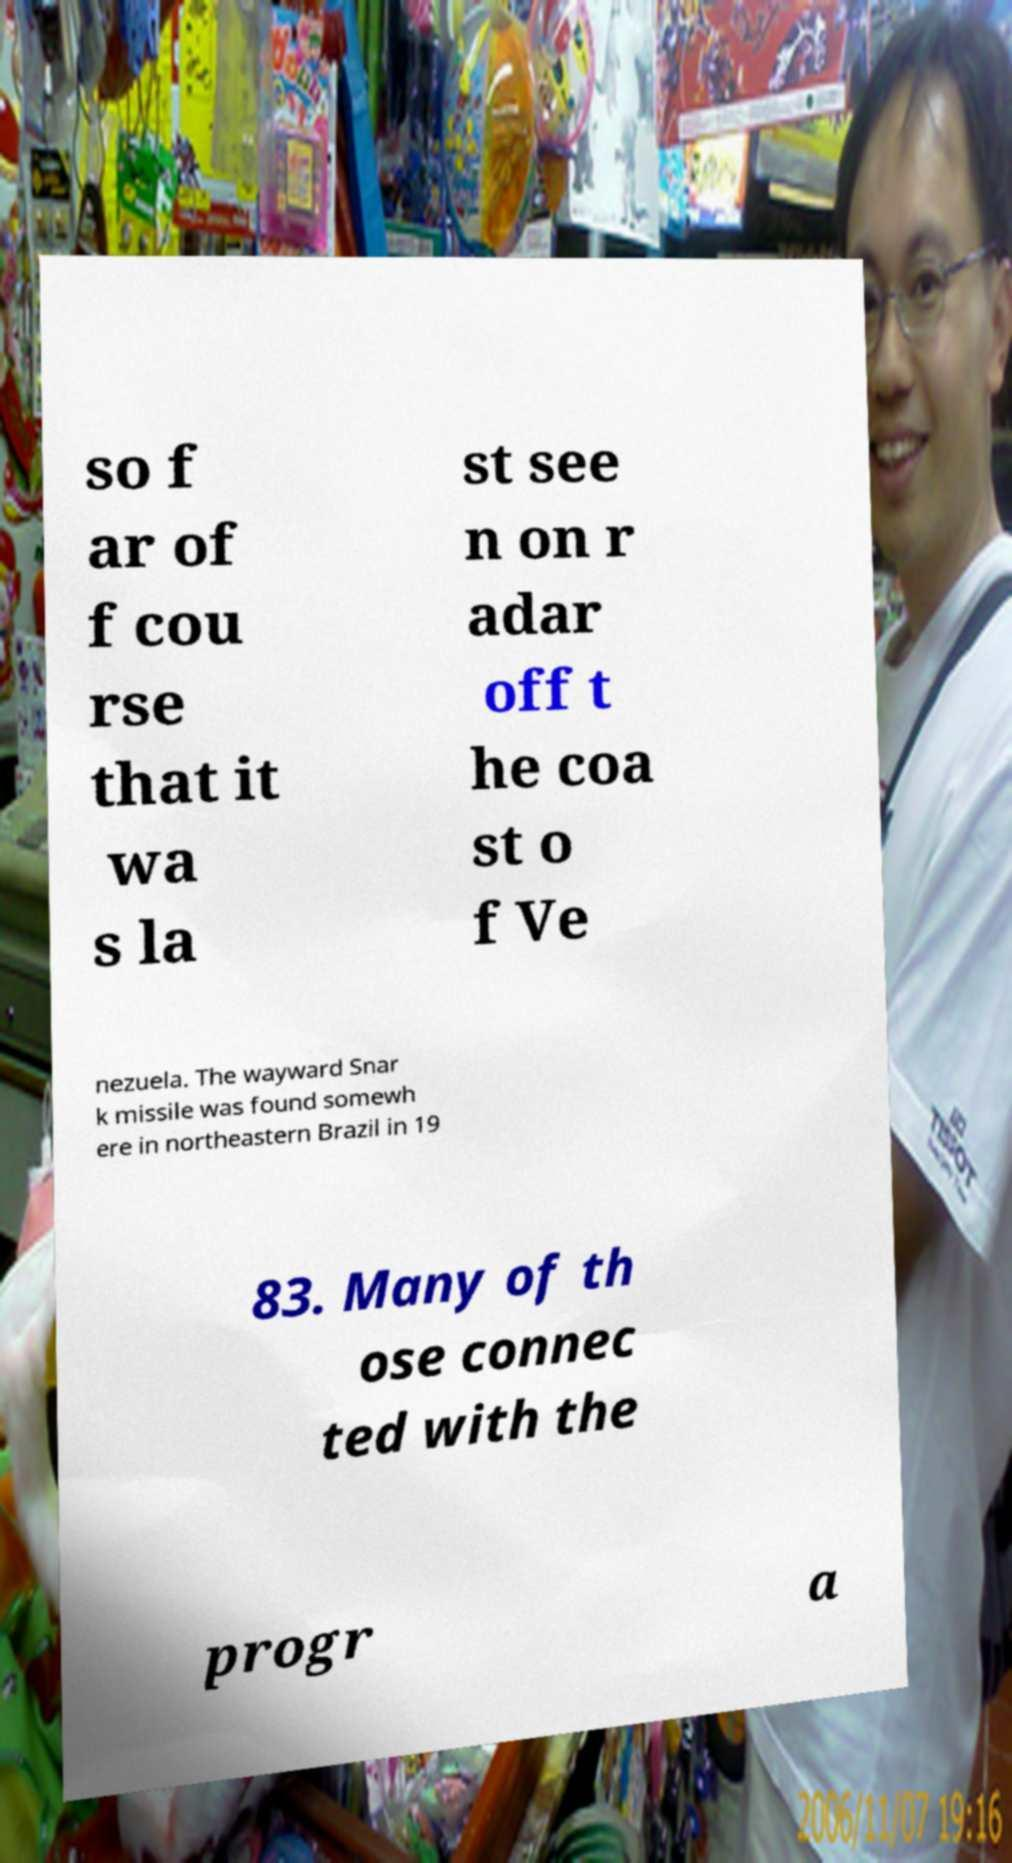Could you extract and type out the text from this image? so f ar of f cou rse that it wa s la st see n on r adar off t he coa st o f Ve nezuela. The wayward Snar k missile was found somewh ere in northeastern Brazil in 19 83. Many of th ose connec ted with the progr a 